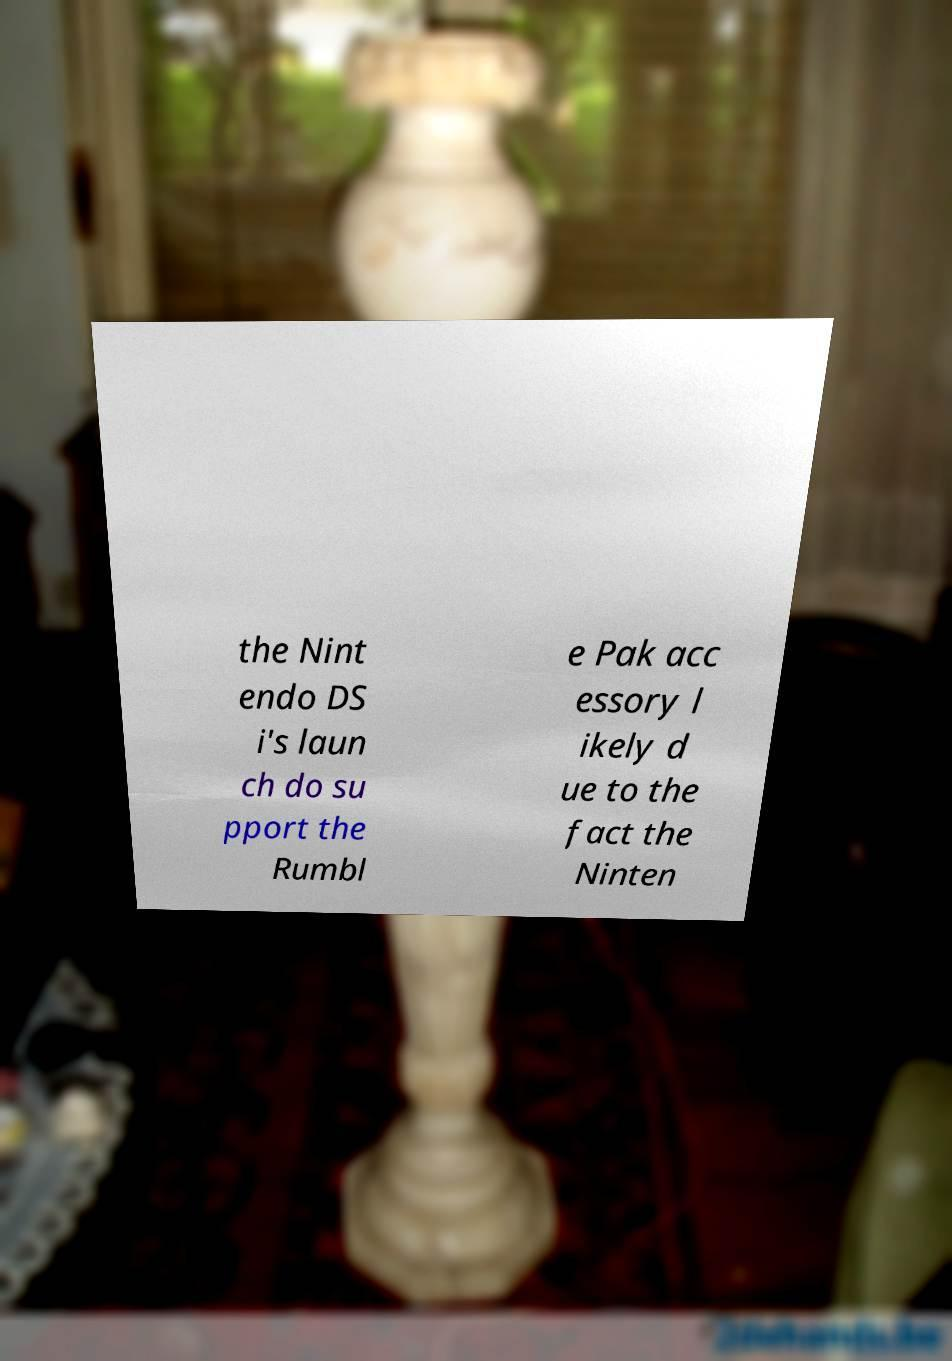I need the written content from this picture converted into text. Can you do that? the Nint endo DS i's laun ch do su pport the Rumbl e Pak acc essory l ikely d ue to the fact the Ninten 